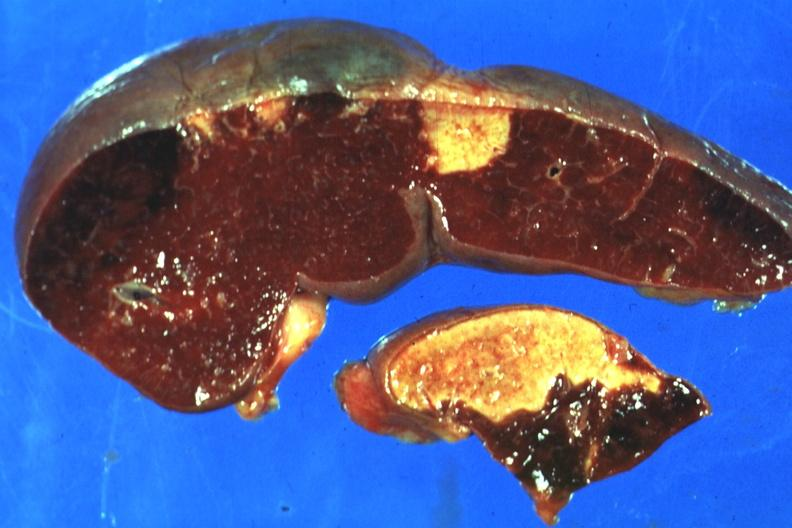s hematologic present?
Answer the question using a single word or phrase. Yes 